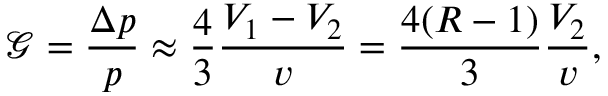<formula> <loc_0><loc_0><loc_500><loc_500>\mathcal { G } = \frac { \Delta p } { p } \approx \frac { 4 } { 3 } \frac { V _ { 1 } - V _ { 2 } } { v } = \frac { 4 ( R - 1 ) } { 3 } \frac { V _ { 2 } } { v } ,</formula> 